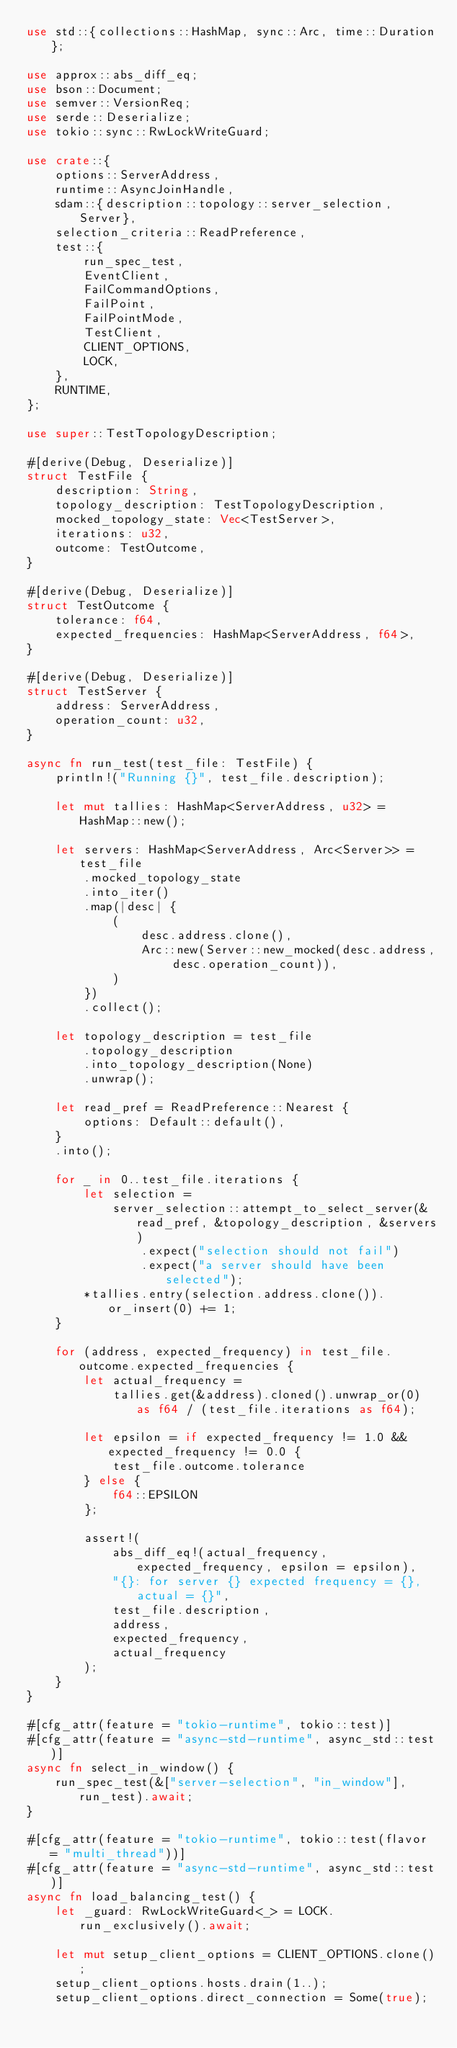<code> <loc_0><loc_0><loc_500><loc_500><_Rust_>use std::{collections::HashMap, sync::Arc, time::Duration};

use approx::abs_diff_eq;
use bson::Document;
use semver::VersionReq;
use serde::Deserialize;
use tokio::sync::RwLockWriteGuard;

use crate::{
    options::ServerAddress,
    runtime::AsyncJoinHandle,
    sdam::{description::topology::server_selection, Server},
    selection_criteria::ReadPreference,
    test::{
        run_spec_test,
        EventClient,
        FailCommandOptions,
        FailPoint,
        FailPointMode,
        TestClient,
        CLIENT_OPTIONS,
        LOCK,
    },
    RUNTIME,
};

use super::TestTopologyDescription;

#[derive(Debug, Deserialize)]
struct TestFile {
    description: String,
    topology_description: TestTopologyDescription,
    mocked_topology_state: Vec<TestServer>,
    iterations: u32,
    outcome: TestOutcome,
}

#[derive(Debug, Deserialize)]
struct TestOutcome {
    tolerance: f64,
    expected_frequencies: HashMap<ServerAddress, f64>,
}

#[derive(Debug, Deserialize)]
struct TestServer {
    address: ServerAddress,
    operation_count: u32,
}

async fn run_test(test_file: TestFile) {
    println!("Running {}", test_file.description);

    let mut tallies: HashMap<ServerAddress, u32> = HashMap::new();

    let servers: HashMap<ServerAddress, Arc<Server>> = test_file
        .mocked_topology_state
        .into_iter()
        .map(|desc| {
            (
                desc.address.clone(),
                Arc::new(Server::new_mocked(desc.address, desc.operation_count)),
            )
        })
        .collect();

    let topology_description = test_file
        .topology_description
        .into_topology_description(None)
        .unwrap();

    let read_pref = ReadPreference::Nearest {
        options: Default::default(),
    }
    .into();

    for _ in 0..test_file.iterations {
        let selection =
            server_selection::attempt_to_select_server(&read_pref, &topology_description, &servers)
                .expect("selection should not fail")
                .expect("a server should have been selected");
        *tallies.entry(selection.address.clone()).or_insert(0) += 1;
    }

    for (address, expected_frequency) in test_file.outcome.expected_frequencies {
        let actual_frequency =
            tallies.get(&address).cloned().unwrap_or(0) as f64 / (test_file.iterations as f64);

        let epsilon = if expected_frequency != 1.0 && expected_frequency != 0.0 {
            test_file.outcome.tolerance
        } else {
            f64::EPSILON
        };

        assert!(
            abs_diff_eq!(actual_frequency, expected_frequency, epsilon = epsilon),
            "{}: for server {} expected frequency = {}, actual = {}",
            test_file.description,
            address,
            expected_frequency,
            actual_frequency
        );
    }
}

#[cfg_attr(feature = "tokio-runtime", tokio::test)]
#[cfg_attr(feature = "async-std-runtime", async_std::test)]
async fn select_in_window() {
    run_spec_test(&["server-selection", "in_window"], run_test).await;
}

#[cfg_attr(feature = "tokio-runtime", tokio::test(flavor = "multi_thread"))]
#[cfg_attr(feature = "async-std-runtime", async_std::test)]
async fn load_balancing_test() {
    let _guard: RwLockWriteGuard<_> = LOCK.run_exclusively().await;

    let mut setup_client_options = CLIENT_OPTIONS.clone();
    setup_client_options.hosts.drain(1..);
    setup_client_options.direct_connection = Some(true);</code> 